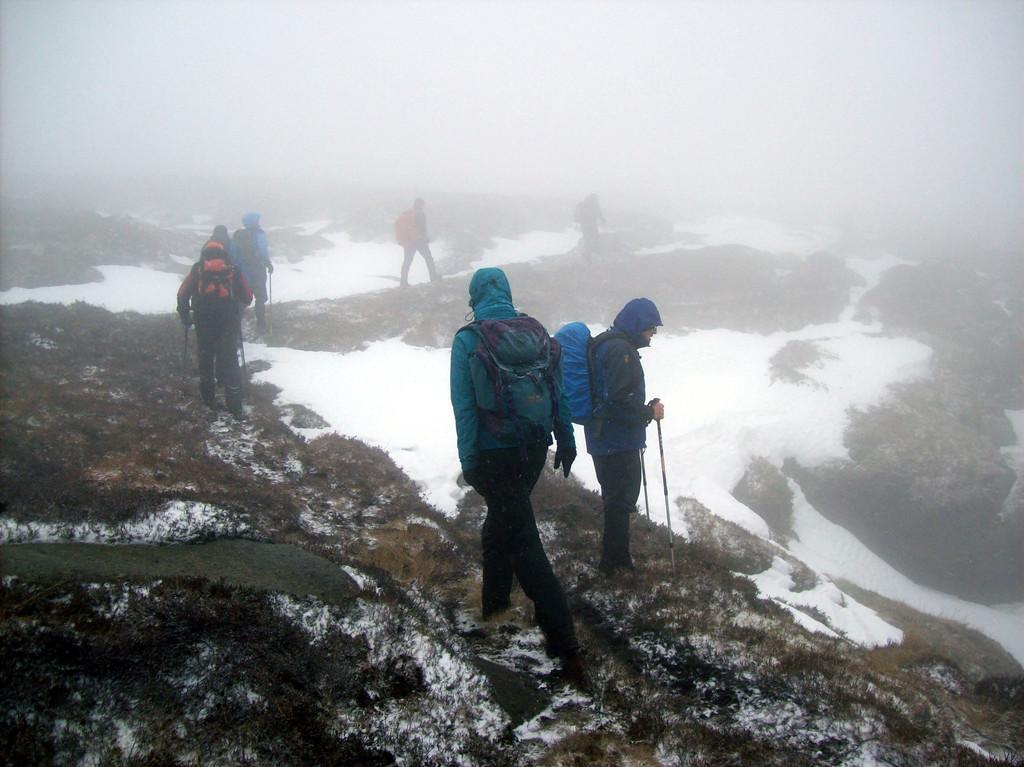Could you give a brief overview of what you see in this image? In this image I can see few people are walking, they wore coats, trousers. On the right side there is the snow, at the top it is the foggy sky. 